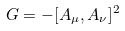<formula> <loc_0><loc_0><loc_500><loc_500>G = - [ A _ { \mu } , A _ { \nu } ] ^ { 2 }</formula> 